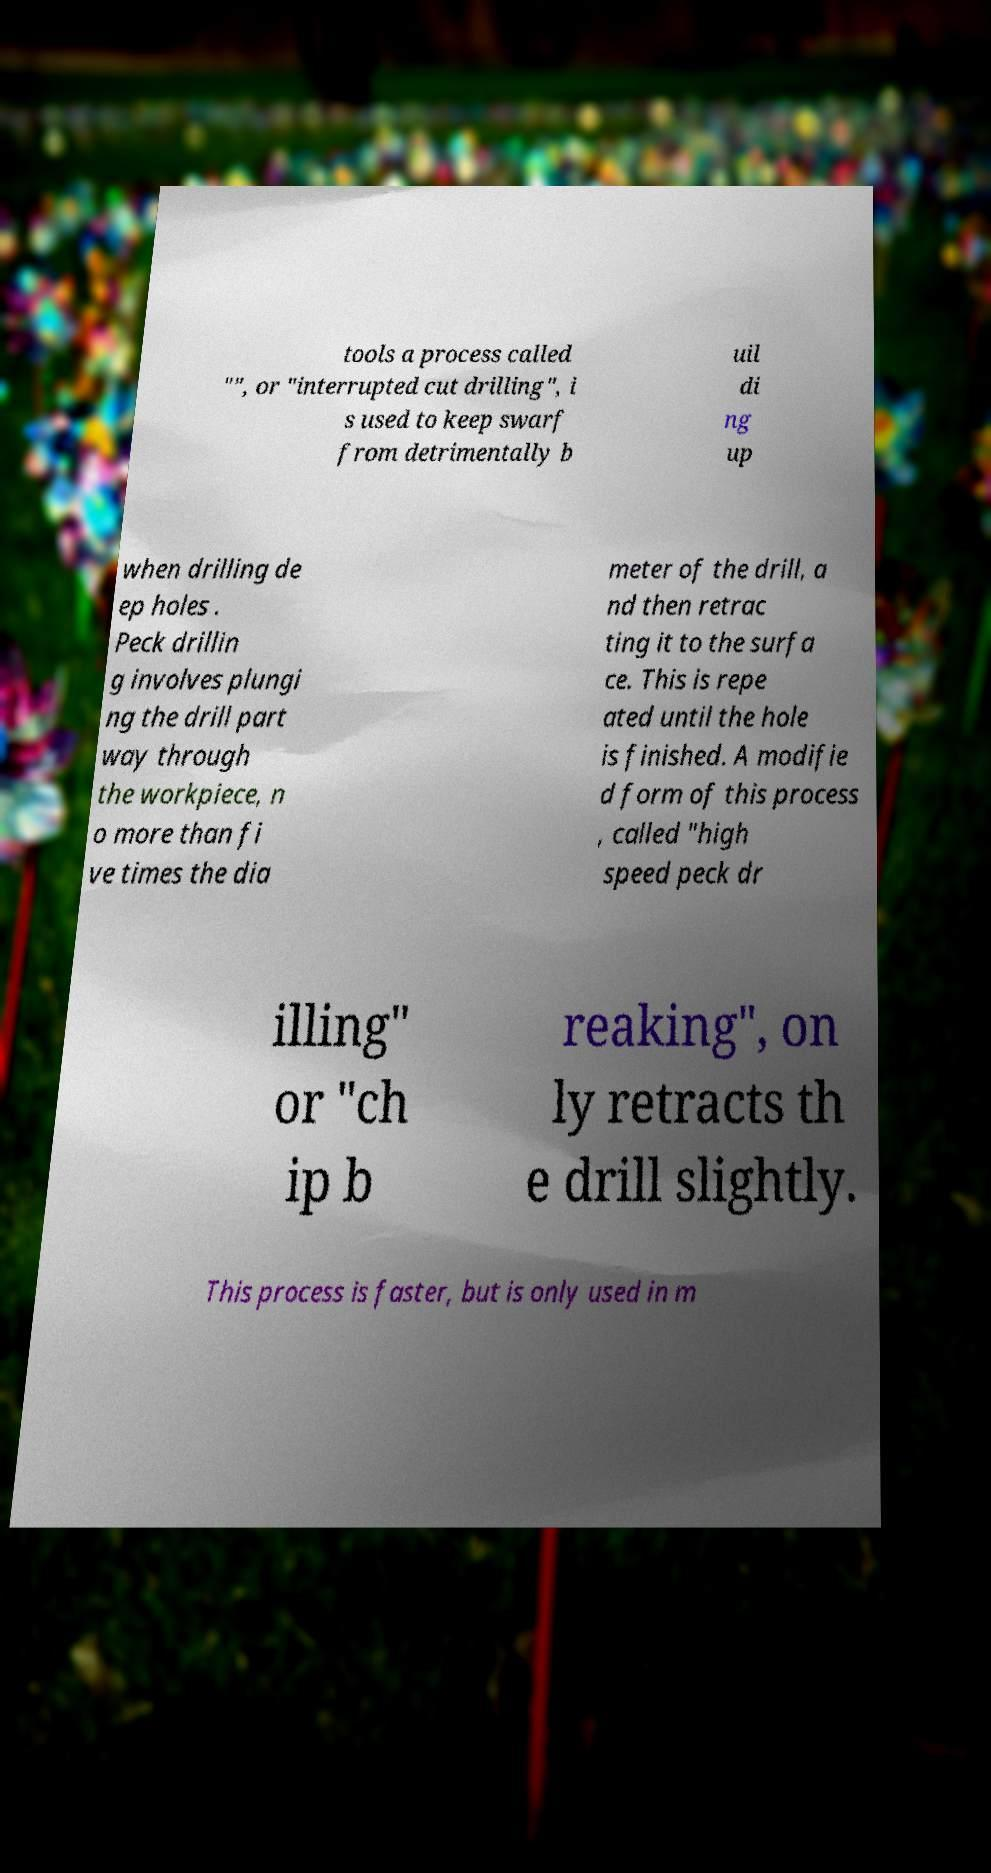For documentation purposes, I need the text within this image transcribed. Could you provide that? tools a process called "", or "interrupted cut drilling", i s used to keep swarf from detrimentally b uil di ng up when drilling de ep holes . Peck drillin g involves plungi ng the drill part way through the workpiece, n o more than fi ve times the dia meter of the drill, a nd then retrac ting it to the surfa ce. This is repe ated until the hole is finished. A modifie d form of this process , called "high speed peck dr illing" or "ch ip b reaking", on ly retracts th e drill slightly. This process is faster, but is only used in m 